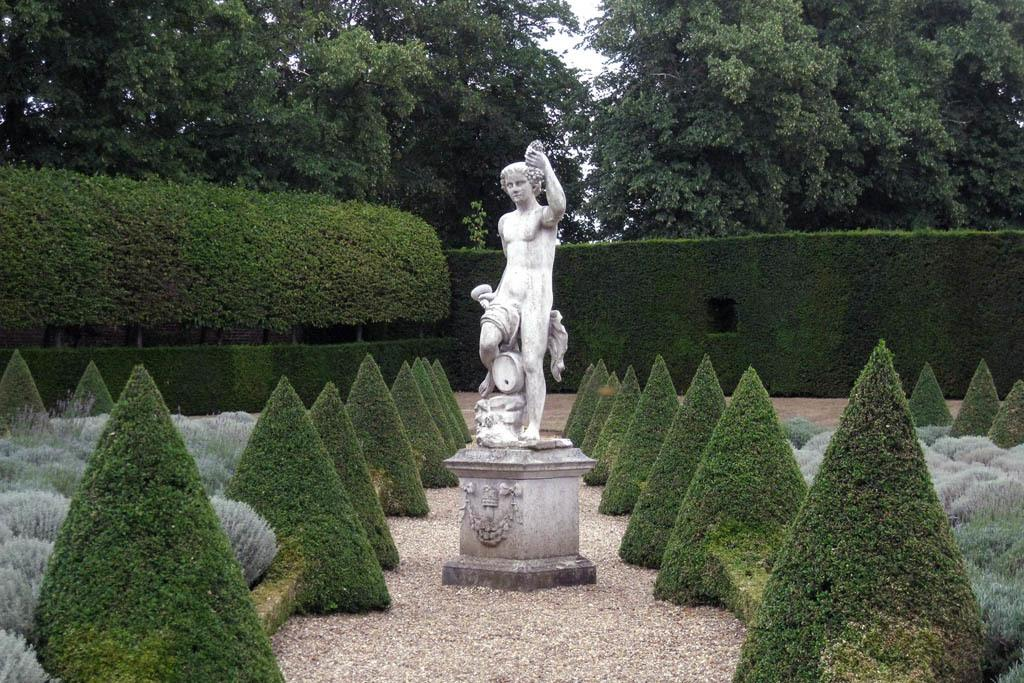What is the main subject in the image? There is a statue in the image. What type of natural elements can be seen in the image? There are trees, plants, and grass visible in the image. What type of leather is used to make the statue in the image? The statue is not made of leather; it is a sculpture made of a different material, such as stone or metal. Can you recite a verse from the poem that is written on the statue in the image? There is no poem written on the statue in the image, so it is not possible to recite a verse. 